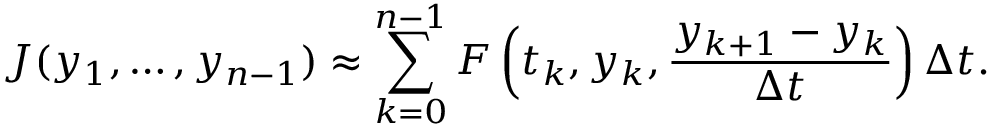Convert formula to latex. <formula><loc_0><loc_0><loc_500><loc_500>J ( y _ { 1 } , \dots , y _ { n - 1 } ) \approx \sum _ { k = 0 } ^ { n - 1 } F \left ( t _ { k } , y _ { k } , { \frac { y _ { k + 1 } - y _ { k } } { \Delta t } } \right ) \Delta t .</formula> 